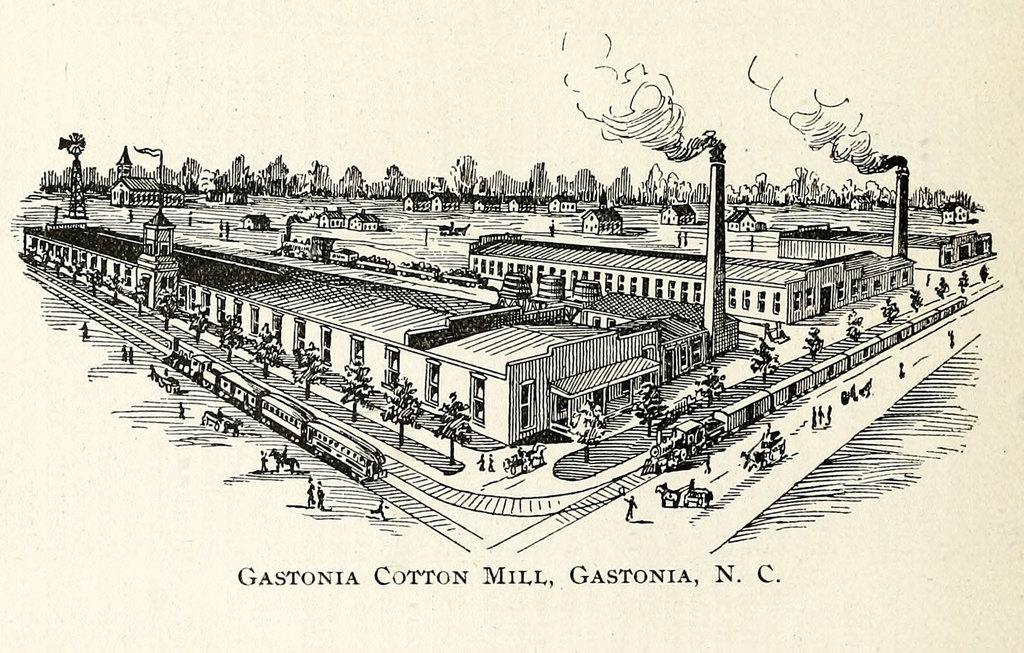What is featured in the image? There is a poster in the image. What elements are included in the poster? The poster includes trees, buildings, and a railway station. Who is the manager of the railway station depicted in the poster? There is no manager mentioned or depicted in the poster, as it only includes images of trees, buildings, and a railway station. 